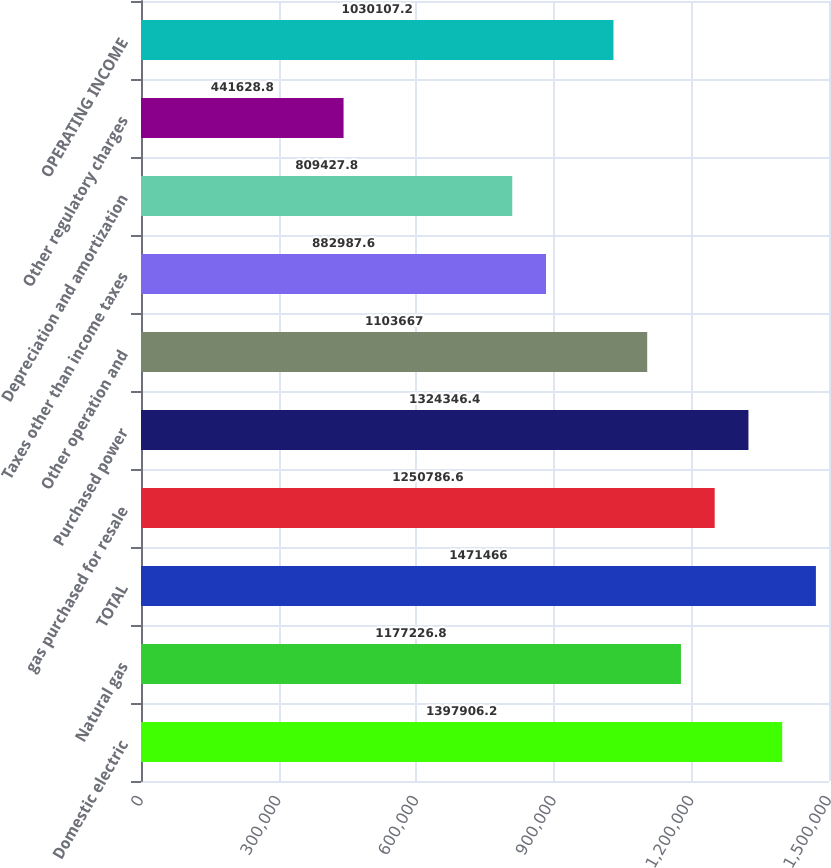<chart> <loc_0><loc_0><loc_500><loc_500><bar_chart><fcel>Domestic electric<fcel>Natural gas<fcel>TOTAL<fcel>gas purchased for resale<fcel>Purchased power<fcel>Other operation and<fcel>Taxes other than income taxes<fcel>Depreciation and amortization<fcel>Other regulatory charges<fcel>OPERATING INCOME<nl><fcel>1.39791e+06<fcel>1.17723e+06<fcel>1.47147e+06<fcel>1.25079e+06<fcel>1.32435e+06<fcel>1.10367e+06<fcel>882988<fcel>809428<fcel>441629<fcel>1.03011e+06<nl></chart> 